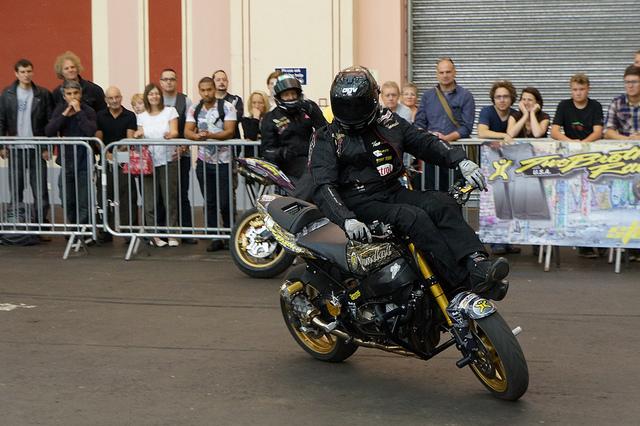Is this a black and white picture?
Be succinct. No. Is the man going to fall off the bike?
Be succinct. No. Which man is driving?
Concise answer only. Front. How many people are on this bike?
Quick response, please. 1. How many people have bikes?
Write a very short answer. 2. What color is the motorcycle?
Quick response, please. Black. 